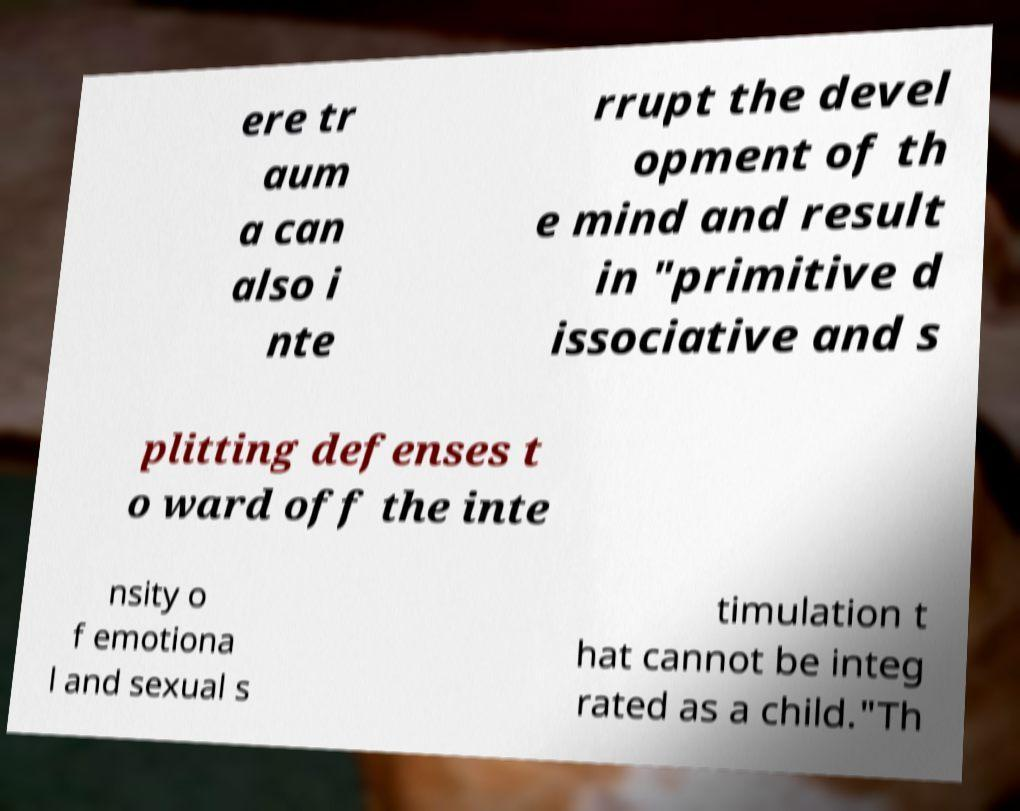Please identify and transcribe the text found in this image. ere tr aum a can also i nte rrupt the devel opment of th e mind and result in "primitive d issociative and s plitting defenses t o ward off the inte nsity o f emotiona l and sexual s timulation t hat cannot be integ rated as a child."Th 